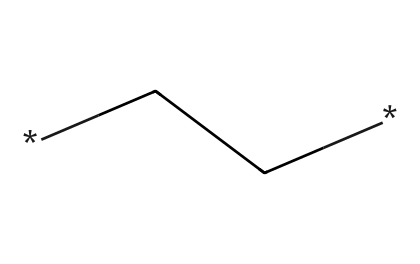What is the name of this aliphatic compound? The structure is composed of a simple chain of carbon (indicated by the "C" in the SMILES). This corresponds to polyethylene, which is a well-known aliphatic compound.
Answer: polyethylene How many carbon atoms are in this structure? The SMILES representation "CC" indicates there are two carbon atoms connected in a chain.
Answer: 2 What type of bonds connect the carbon atoms in this compound? In aliphatic compounds like polyethylene, the carbon atoms are connected by single bonds, as evidenced by the absence of any double or triple bonds in the "CC" notation.
Answer: single bonds Is this compound soluble in water? Polyethylene, being a hydrophobic aliphatic compound, does not dissolve well in water due to its long carbon chain structure, which does not interact favorably with a polar solvent like water.
Answer: no What is a common use for this compound in the context of athletes? Polyethylene is commonly used in the production of water bottles for athletes, due to its durability and resistance to impact and stress.
Answer: water bottles How does the structure influence the flexibility of this polymer? The long chain of carbon atoms (as represented in the SMILES "CC") allows for significant rotation around the carbon-carbon bonds, providing polyethylene with flexibility, which is an essential property for its use in bottles.
Answer: flexibility What is a primary property of polyethylene that makes it suitable for aquatic sports? The low density of polyethylene makes it float and be lightweight, which is advantageous for water-related activities and for transporting fluids efficiently.
Answer: low density 